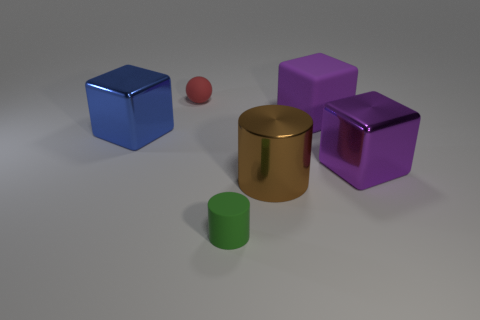There is another object that is the same size as the red rubber object; what color is it? The object that matches the size of the small red rubber ball appears to be a green cylinder. Despite its different shape, its size is comparable to the red ball's. 